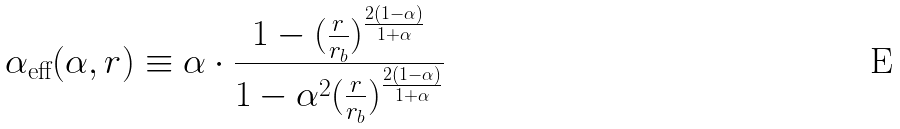<formula> <loc_0><loc_0><loc_500><loc_500>\alpha _ { \text {eff} } ( \alpha , r ) \equiv \alpha \cdot \frac { 1 - ( \frac { r } { r _ { b } } ) ^ { \frac { 2 ( 1 - \alpha ) } { 1 + \alpha } } } { 1 - \alpha ^ { 2 } ( \frac { r } { r _ { b } } ) ^ { \frac { 2 ( 1 - \alpha ) } { 1 + \alpha } } }</formula> 